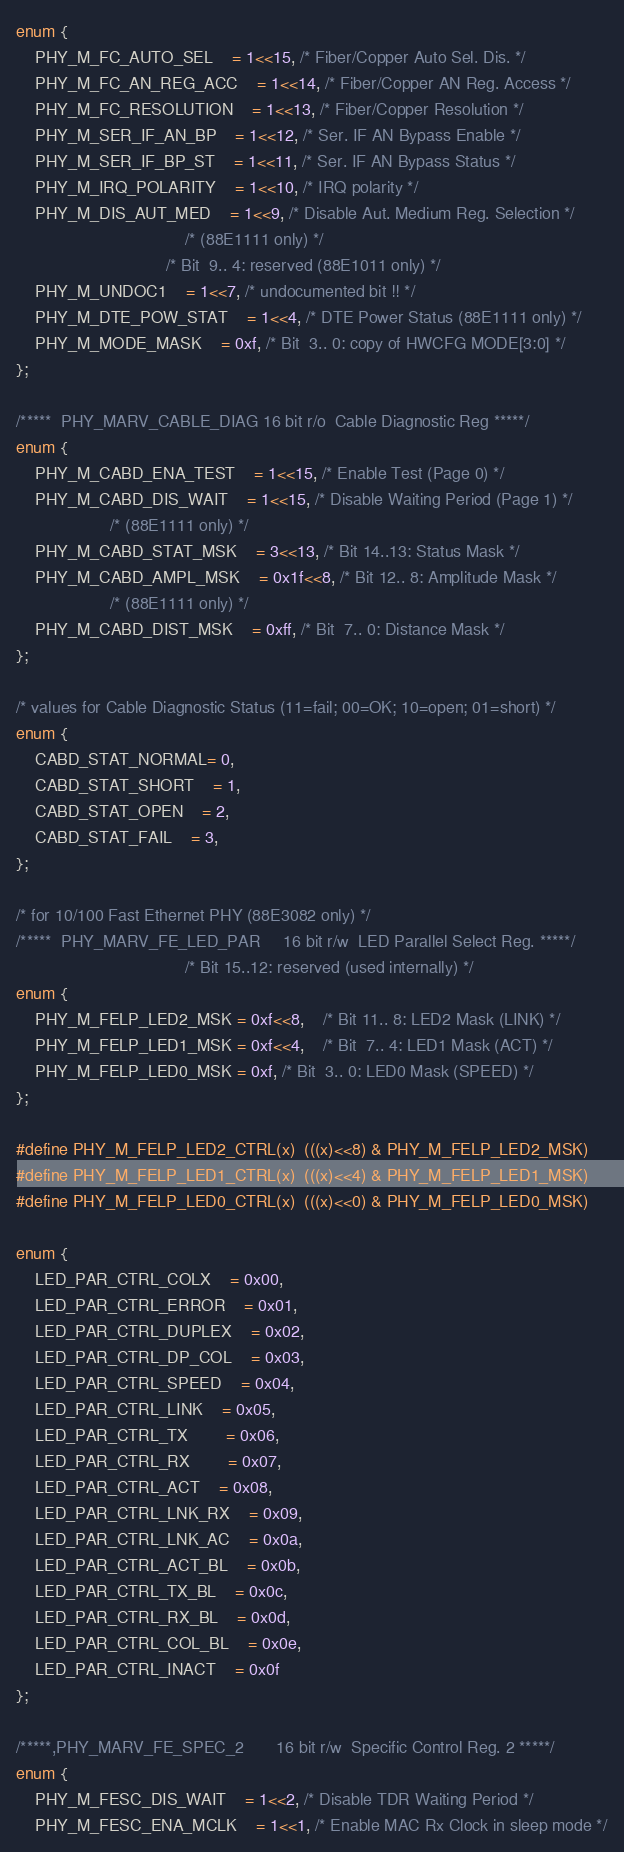<code> <loc_0><loc_0><loc_500><loc_500><_C_>enum {
	PHY_M_FC_AUTO_SEL	= 1<<15, /* Fiber/Copper Auto Sel. Dis. */
	PHY_M_FC_AN_REG_ACC	= 1<<14, /* Fiber/Copper AN Reg. Access */
	PHY_M_FC_RESOLUTION	= 1<<13, /* Fiber/Copper Resolution */
	PHY_M_SER_IF_AN_BP	= 1<<12, /* Ser. IF AN Bypass Enable */
	PHY_M_SER_IF_BP_ST	= 1<<11, /* Ser. IF AN Bypass Status */
	PHY_M_IRQ_POLARITY	= 1<<10, /* IRQ polarity */
	PHY_M_DIS_AUT_MED	= 1<<9, /* Disable Aut. Medium Reg. Selection */
									/* (88E1111 only) */
								/* Bit  9.. 4: reserved (88E1011 only) */
	PHY_M_UNDOC1	= 1<<7, /* undocumented bit !! */
	PHY_M_DTE_POW_STAT	= 1<<4, /* DTE Power Status (88E1111 only) */
	PHY_M_MODE_MASK	= 0xf, /* Bit  3.. 0: copy of HWCFG MODE[3:0] */
};

/*****  PHY_MARV_CABLE_DIAG	16 bit r/o	Cable Diagnostic Reg *****/
enum {
	PHY_M_CABD_ENA_TEST	= 1<<15, /* Enable Test (Page 0) */
	PHY_M_CABD_DIS_WAIT	= 1<<15, /* Disable Waiting Period (Page 1) */
					/* (88E1111 only) */
	PHY_M_CABD_STAT_MSK	= 3<<13, /* Bit 14..13: Status Mask */
	PHY_M_CABD_AMPL_MSK	= 0x1f<<8, /* Bit 12.. 8: Amplitude Mask */
					/* (88E1111 only) */
	PHY_M_CABD_DIST_MSK	= 0xff, /* Bit  7.. 0: Distance Mask */
};

/* values for Cable Diagnostic Status (11=fail; 00=OK; 10=open; 01=short) */
enum {
	CABD_STAT_NORMAL= 0,
	CABD_STAT_SHORT	= 1,
	CABD_STAT_OPEN	= 2,
	CABD_STAT_FAIL	= 3,
};

/* for 10/100 Fast Ethernet PHY (88E3082 only) */
/*****  PHY_MARV_FE_LED_PAR		16 bit r/w	LED Parallel Select Reg. *****/
									/* Bit 15..12: reserved (used internally) */
enum {
	PHY_M_FELP_LED2_MSK = 0xf<<8,	/* Bit 11.. 8: LED2 Mask (LINK) */
	PHY_M_FELP_LED1_MSK = 0xf<<4,	/* Bit  7.. 4: LED1 Mask (ACT) */
	PHY_M_FELP_LED0_MSK = 0xf, /* Bit  3.. 0: LED0 Mask (SPEED) */
};

#define PHY_M_FELP_LED2_CTRL(x)	(((x)<<8) & PHY_M_FELP_LED2_MSK)
#define PHY_M_FELP_LED1_CTRL(x)	(((x)<<4) & PHY_M_FELP_LED1_MSK)
#define PHY_M_FELP_LED0_CTRL(x)	(((x)<<0) & PHY_M_FELP_LED0_MSK)

enum {
	LED_PAR_CTRL_COLX	= 0x00,
	LED_PAR_CTRL_ERROR	= 0x01,
	LED_PAR_CTRL_DUPLEX	= 0x02,
	LED_PAR_CTRL_DP_COL	= 0x03,
	LED_PAR_CTRL_SPEED	= 0x04,
	LED_PAR_CTRL_LINK	= 0x05,
	LED_PAR_CTRL_TX		= 0x06,
	LED_PAR_CTRL_RX		= 0x07,
	LED_PAR_CTRL_ACT	= 0x08,
	LED_PAR_CTRL_LNK_RX	= 0x09,
	LED_PAR_CTRL_LNK_AC	= 0x0a,
	LED_PAR_CTRL_ACT_BL	= 0x0b,
	LED_PAR_CTRL_TX_BL	= 0x0c,
	LED_PAR_CTRL_RX_BL	= 0x0d,
	LED_PAR_CTRL_COL_BL	= 0x0e,
	LED_PAR_CTRL_INACT	= 0x0f
};

/*****,PHY_MARV_FE_SPEC_2		16 bit r/w	Specific Control Reg. 2 *****/
enum {
	PHY_M_FESC_DIS_WAIT	= 1<<2, /* Disable TDR Waiting Period */
	PHY_M_FESC_ENA_MCLK	= 1<<1, /* Enable MAC Rx Clock in sleep mode */</code> 